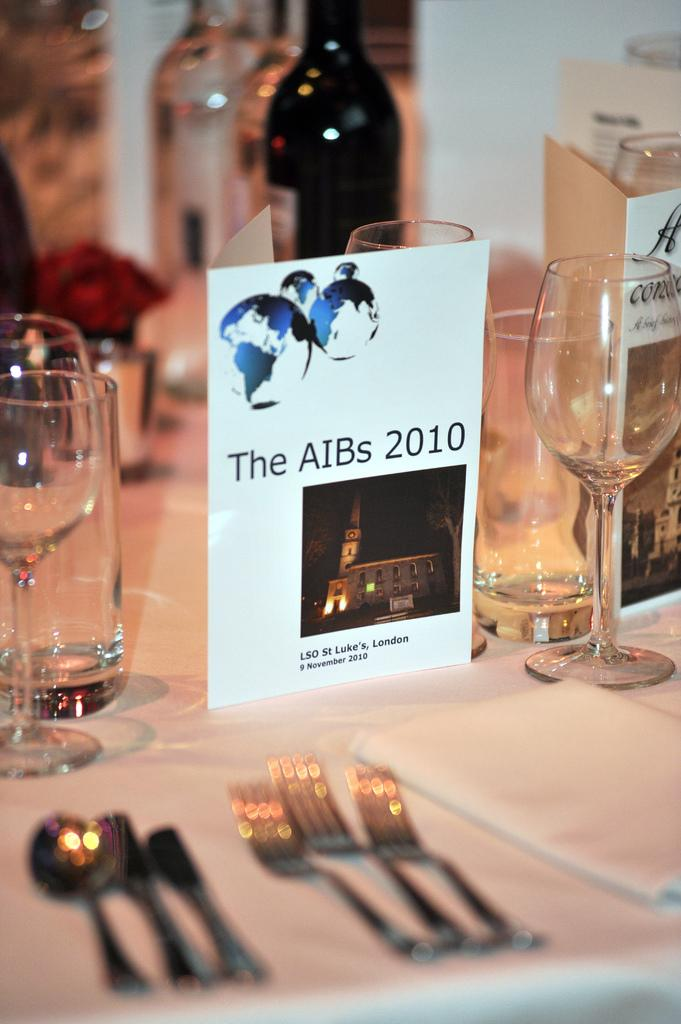What type of objects are on the table in the image? There are glasses, bottles, spoons, tissues, and a note on the table. What might be used for drinking in the image? The glasses on the table might be used for drinking. What might be used for eating in the image? The spoons on the table might be used for eating. What might be used for cleaning or wiping in the image? The tissues on the table might be used for cleaning or wiping. What is the color of the note on the table? The note on the table is white in color. What type of loaf is present on the table in the image? There is no loaf present on the table in the image. What type of operation is being performed on the stomach in the image? There is no operation or reference to a stomach in the image. 